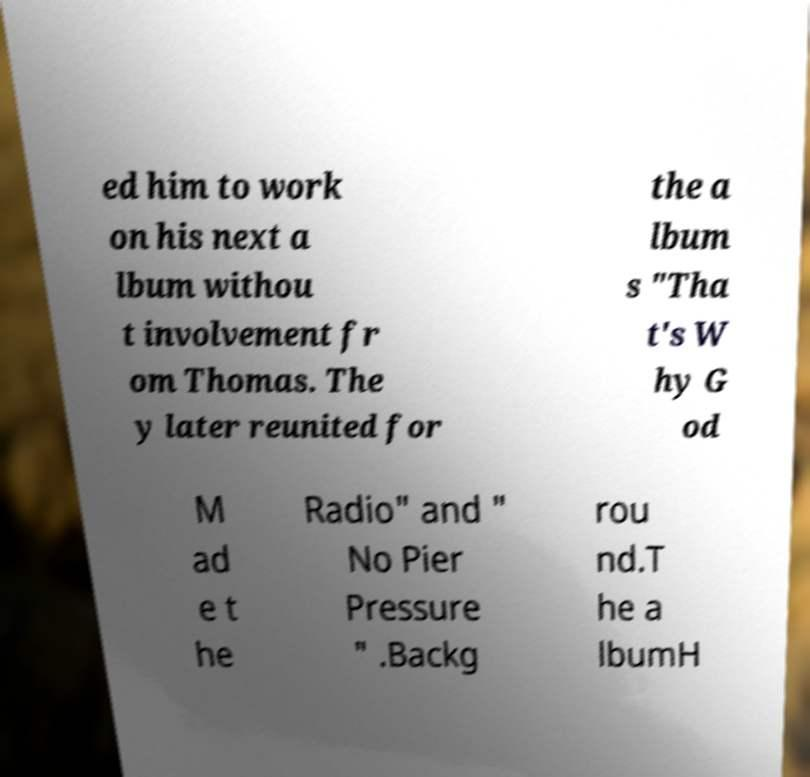Can you accurately transcribe the text from the provided image for me? ed him to work on his next a lbum withou t involvement fr om Thomas. The y later reunited for the a lbum s "Tha t's W hy G od M ad e t he Radio" and " No Pier Pressure " .Backg rou nd.T he a lbumH 